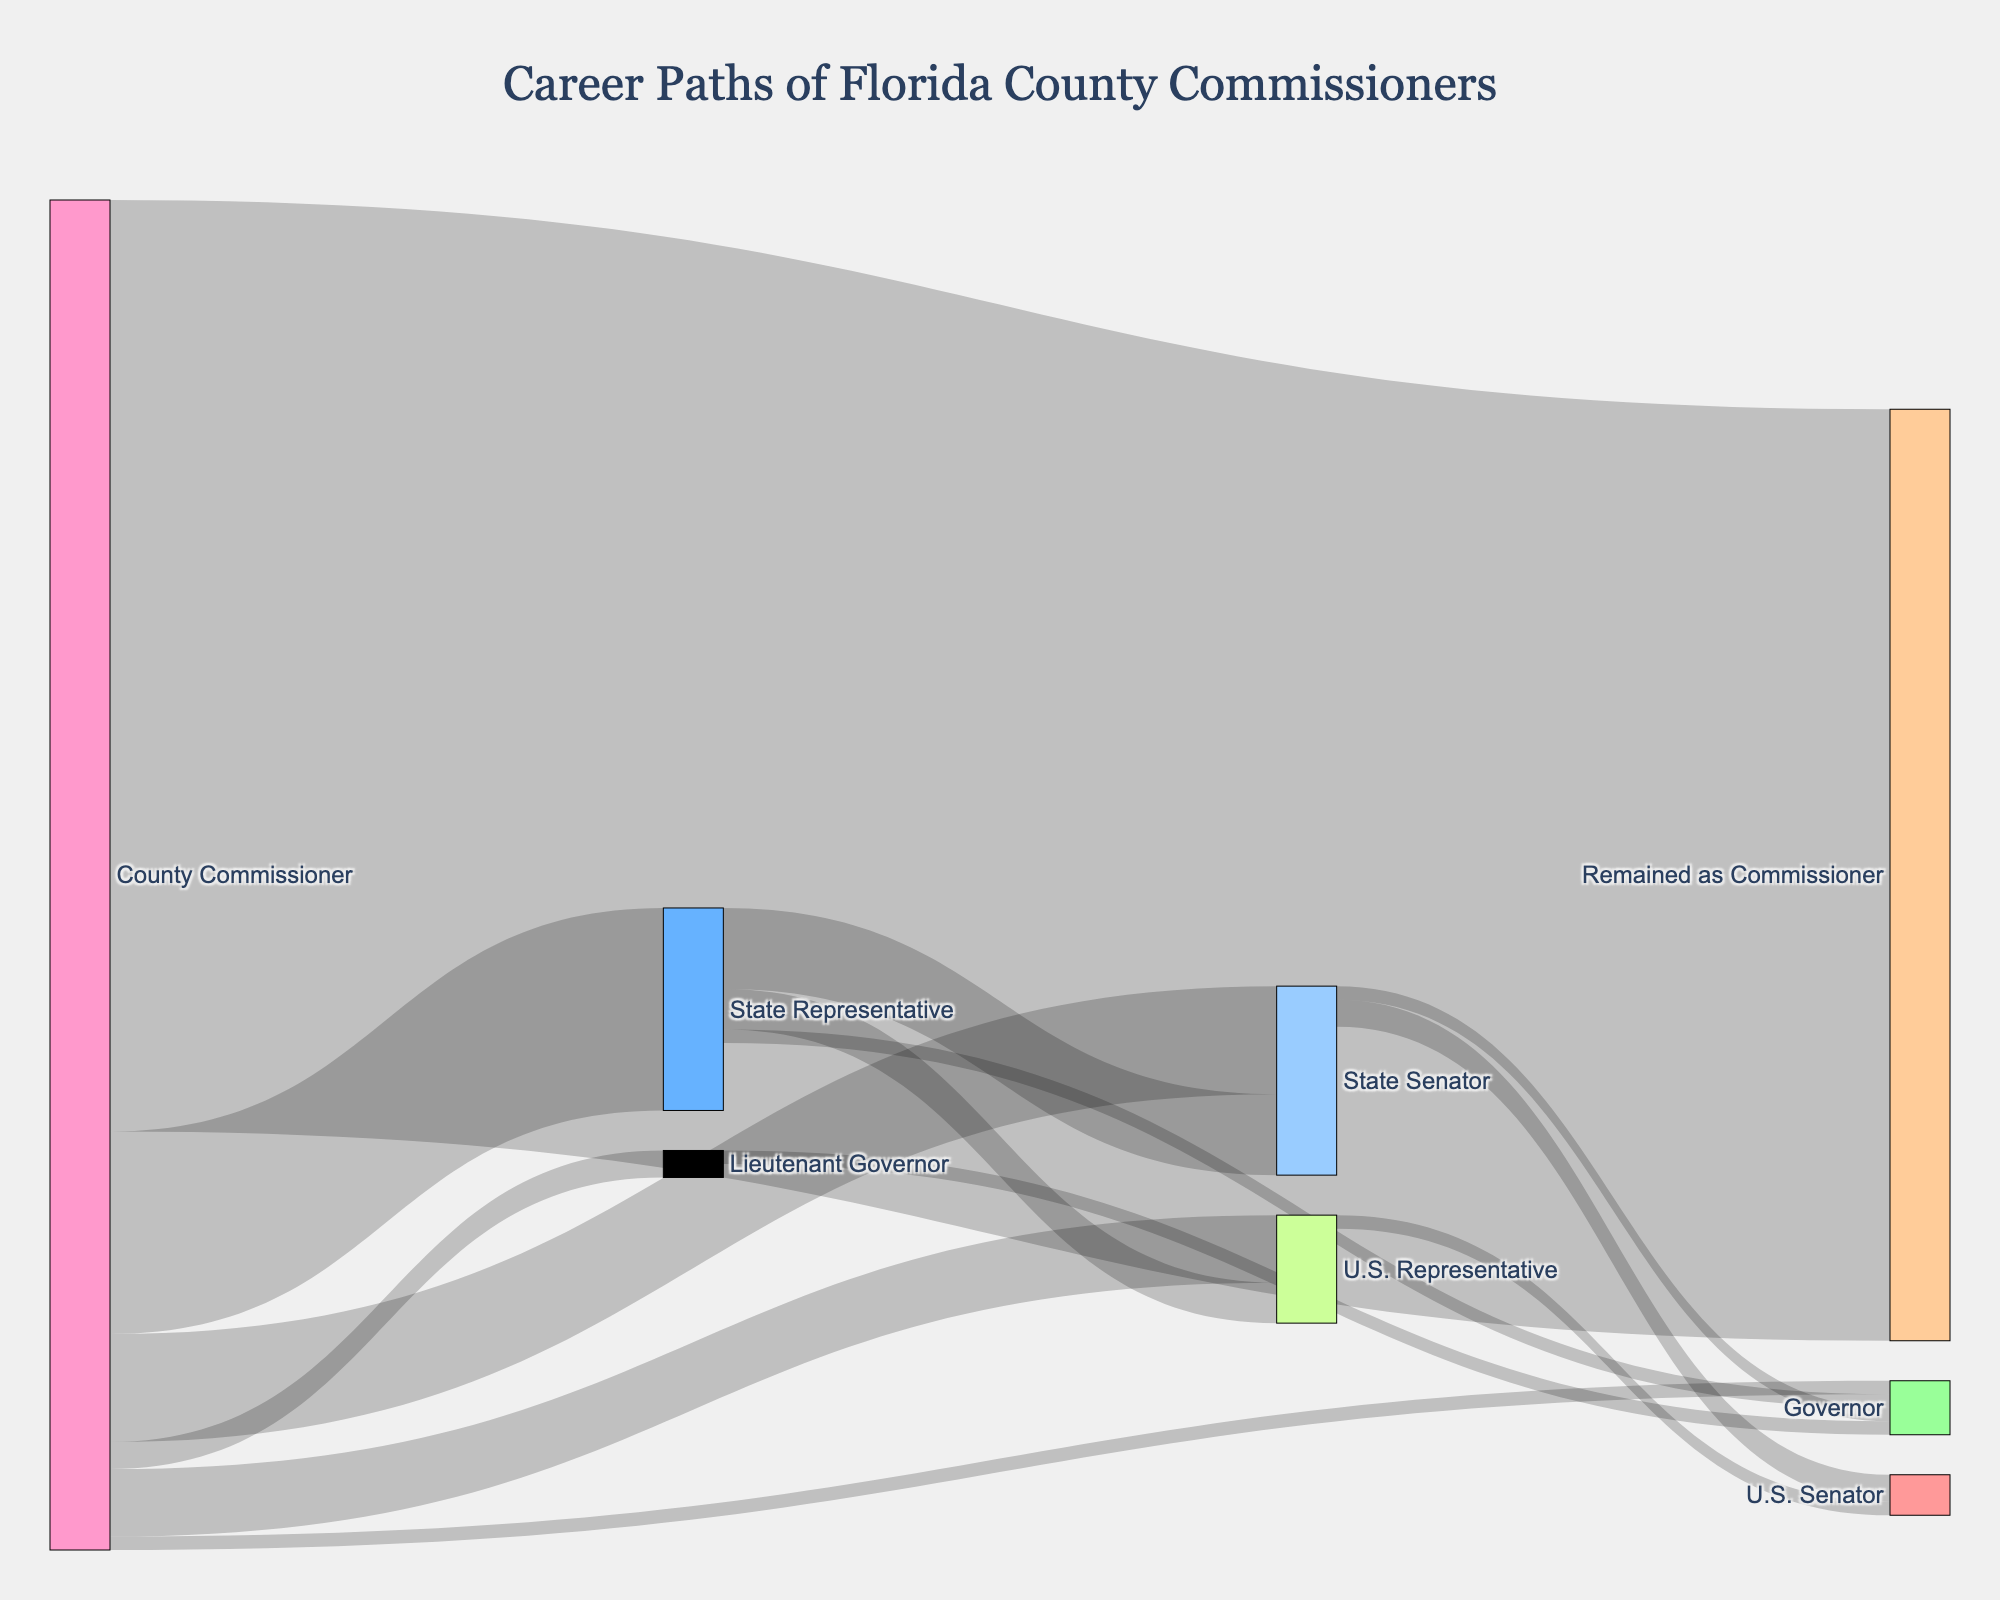what is the most common career path for County Commissioners in Florida? The largest flow in the Sankey diagram originates from the County Commissioner node and flows to Remained as Commissioner with a value of 69. This suggests that the most common career path for County Commissioners is to remain in their current position.
Answer: Remained as Commissioner How many County Commissioners have transitioned to State-level legislative roles? To determine this, sum the values of County Commissioner to State Representative (15) and County Commissioner to State Senator (8). Therefore, the total is 15 + 8 = 23.
Answer: 23 Out of the County Commissioners who moved to state-level jobs, how many eventually became a Governor? We need to consider those who moved to State Representative (Governor: 1) and State Senator (Governor: 1). So the total value is 1 + 1 = 2.
Answer: 2 Which career move from County Commissioner to state-level or federal positions is the least common? The smallest values originating from County Commissioner are to Lieutenant Governor (2) and Governor (1). Thus, the move to Governor (1) is the least common.
Answer: Governor Which political position appears to serve as a stepping stone to U.S. Senator, based on the career paths of Florida County Commissioners? The path to U.S. Senator comes from the State Senator to U.S. Senator (2) and U.S. Representative to U.S. Senator (1). Therefore, State Senator most commonly serves as a stepping stone.
Answer: State Senator How many career advancements in total are documented for County Commissioners who did not remain in their position? Adding the values for all target positions except "Remained as Commissioner" gives: 15 (State Representative) + 8 (State Senator) + 2 (Lieutenant Governor) + 1 (Governor) + 5 (U.S. Representative) = 31.
Answer: 31 For those County Commissioners who advance to the State Representative role, how many subsequently move on to higher political offices? Summing the values for career advancements from State Representative to State Senator (6), U.S. Representative (3), and Governor (1), we get 6 + 3 + 1 = 10.
Answer: 10 How many County Commissioners have made it to U.S. Representative and how many from there proceeded to higher roles? From the County Commissioner node to U.S. Representative, 5 moved. From U.S. Representative to U.S. Senator, 1 moved.
Answer: 5; 1 What is the overall probability of a County Commissioner in Florida eventually becoming a U.S. Senator? Trace the flows: County Commissioner to State Senator (8), from there to U.S. Senator (2) gives a path probability of 8 x 2/8 = 2. From County Commissioner to U.S. Representative (5), from there to U.S. Senator (1), gives a path probability of 5 x 1/5 = 1. Adding these gives a total of 2+1=3 for starting from 100 Commissioner giving probability 3/100=3%.
Answer: 3% Which position exclusively leads to the Governor role without intermediary positions? From the given data, the only position leading to Governor directly is the Lieutenant Governor to Governor (1).
Answer: Lieutenant Governor 